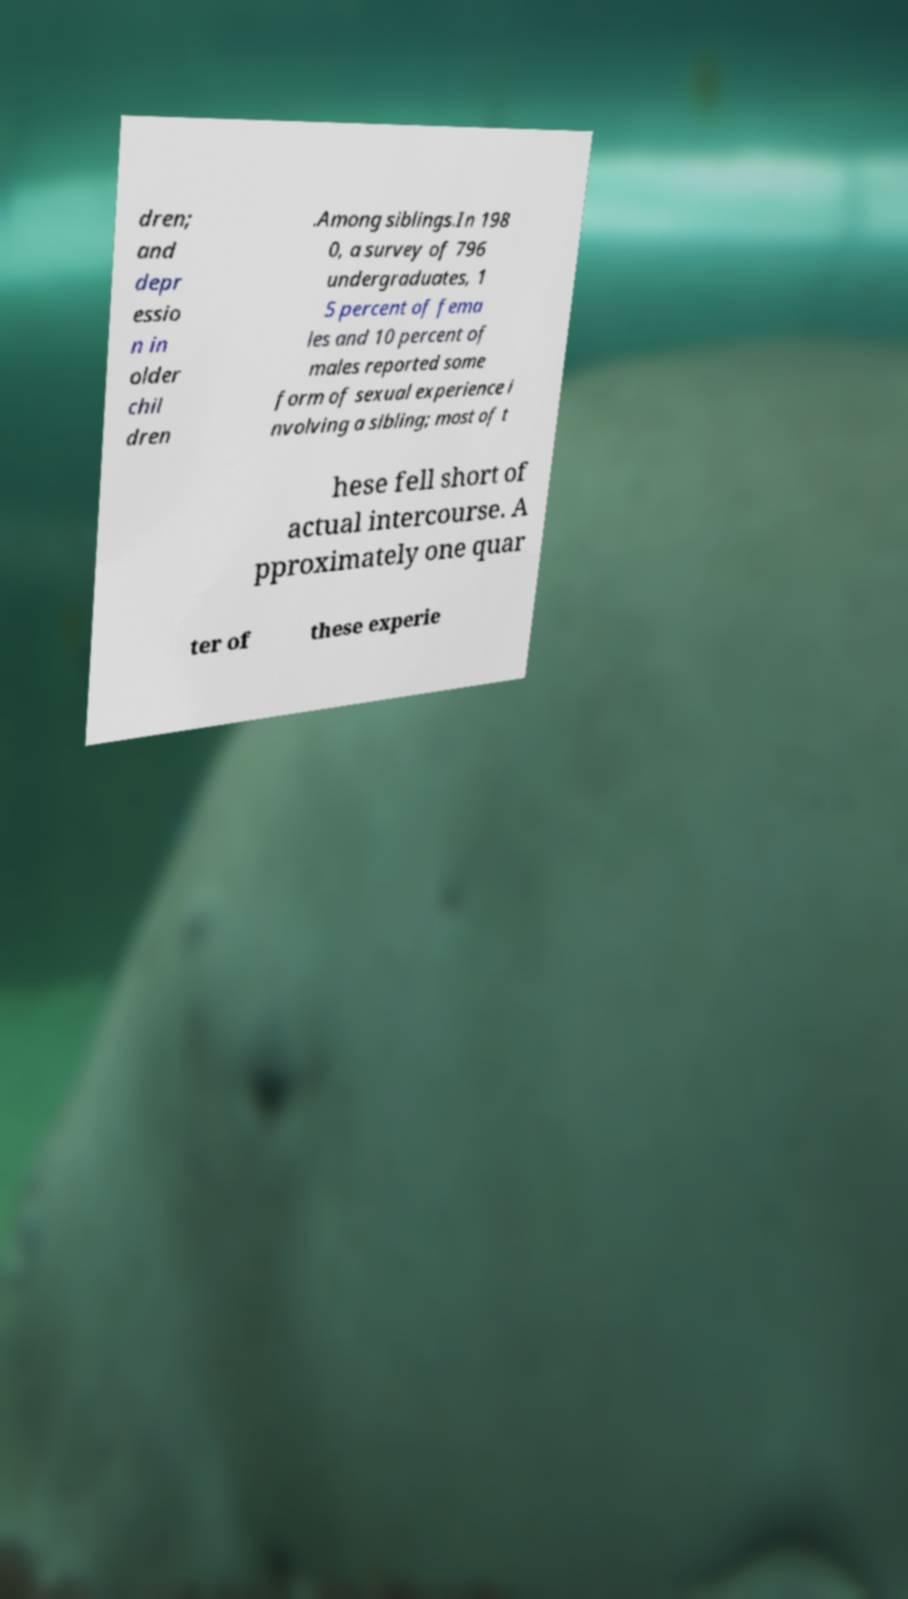Please read and relay the text visible in this image. What does it say? dren; and depr essio n in older chil dren .Among siblings.In 198 0, a survey of 796 undergraduates, 1 5 percent of fema les and 10 percent of males reported some form of sexual experience i nvolving a sibling; most of t hese fell short of actual intercourse. A pproximately one quar ter of these experie 